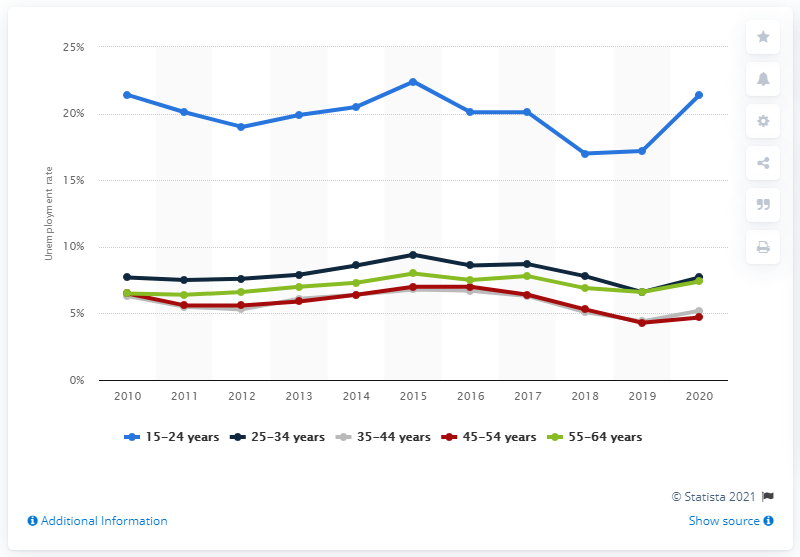Indicate a few pertinent items in this graphic. In 2020, the unemployment rate in Finland was 7.9%. 